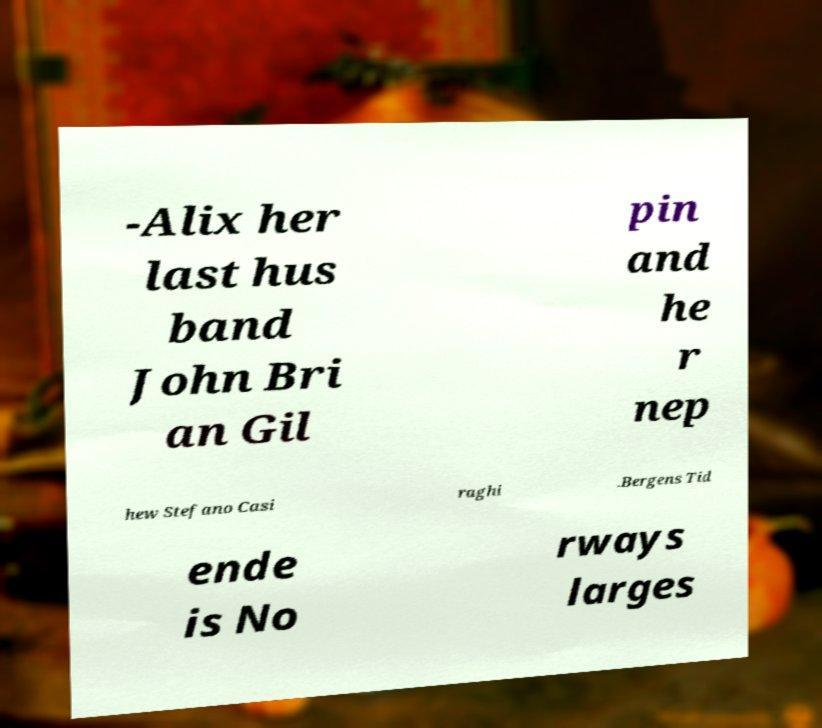Could you assist in decoding the text presented in this image and type it out clearly? -Alix her last hus band John Bri an Gil pin and he r nep hew Stefano Casi raghi .Bergens Tid ende is No rways larges 